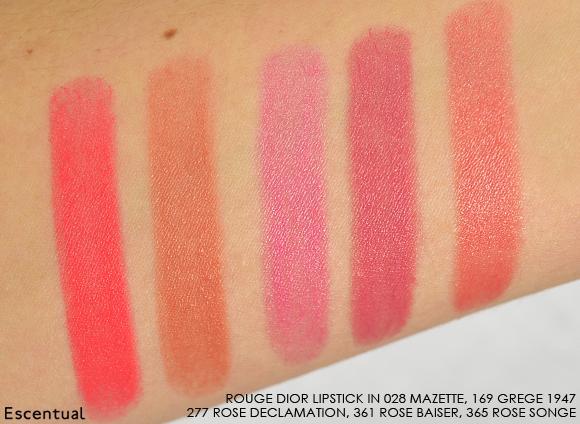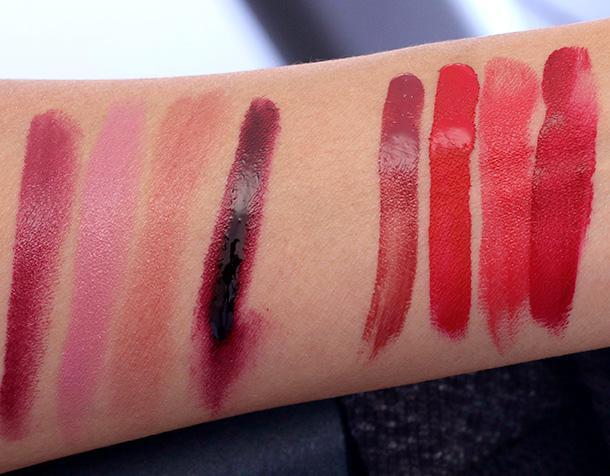The first image is the image on the left, the second image is the image on the right. Evaluate the accuracy of this statement regarding the images: "There are at least 13 stripes of different lipstick colors on the arms.". Is it true? Answer yes or no. Yes. 